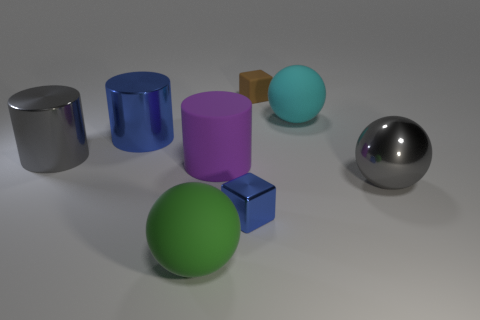Subtract all big green balls. How many balls are left? 2 Add 2 brown things. How many objects exist? 10 Subtract 2 balls. How many balls are left? 1 Add 7 brown matte objects. How many brown matte objects exist? 8 Subtract all purple cylinders. How many cylinders are left? 2 Subtract 0 red cubes. How many objects are left? 8 Subtract all spheres. How many objects are left? 5 Subtract all green cylinders. Subtract all blue cubes. How many cylinders are left? 3 Subtract all blue shiny things. Subtract all small objects. How many objects are left? 4 Add 4 big gray balls. How many big gray balls are left? 5 